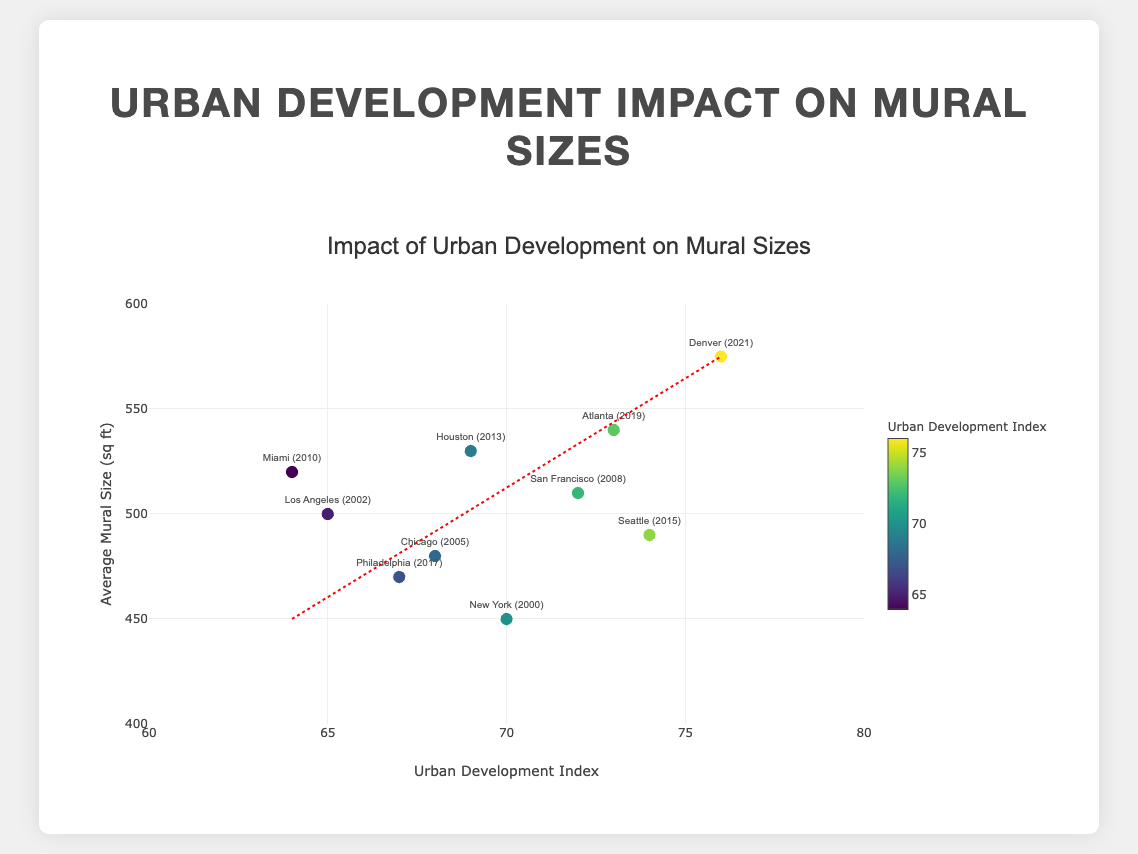What's the title of the plot? The title is displayed prominently at the top of the plot. It reads "Impact of Urban Development on Mural Sizes".
Answer: "Impact of Urban Development on Mural Sizes" What is shown on the y-axis? The y-axis label indicates the metric being measured. The y-axis shows "Average Mural Size (sq ft)".
Answer: "Average Mural Size (sq ft)" Which city and year correspond to the largest average mural size? By looking at the points and tooltips, the data point with the highest y-value is for Denver in the year 2021.
Answer: "Denver (2021)" What is the trend of the relationship between urban development index and average mural size according to the trend line? The trend line in the scatter plot shows an upward slope, indicating a positive relationship between urban development index and average mural size.
Answer: Positive relationship How many data points are represented in the plot? Counting the marker points displayed on the plot, there are a total of 10 data points.
Answer: 10 Which two cities have the closest average mural size and what are their sizes? By closely examining the y-axis and markers, Miami and Chicago have very close average mural sizes (Miami: 520 sq ft and Chicago: 480 sq ft).
Answer: "Miami (520 sq ft) and Chicago (480 sq ft)" Between which years was the most significant increase in mural size observed? Observing the individual years and average mural sizes, the largest increase is between 2019 and 2021 (Atlanta: 540 sq ft to Denver: 575 sq ft).
Answer: Between 2019 and 2021 Which data point has the smallest urban development index and what is its corresponding mural size? Identifying the point with the smallest x-axis value, Miami in 2010 has the smallest urban development index of 64 with an average mural size of 520 sq ft.
Answer: Miami (520 sq ft) Is there any city with an average mural size below 450 sq ft? By checking the lowest y-axis values of the data points, all cities have average mural sizes above 450 sq ft.
Answer: No What's the average urban development index for the presented data points? Summing all urban development index values (70+65+68+72+64+69+74+67+73+76=698) and then dividing by the total number of data points (10), the average urban development index is 69.8.
Answer: 69.8 